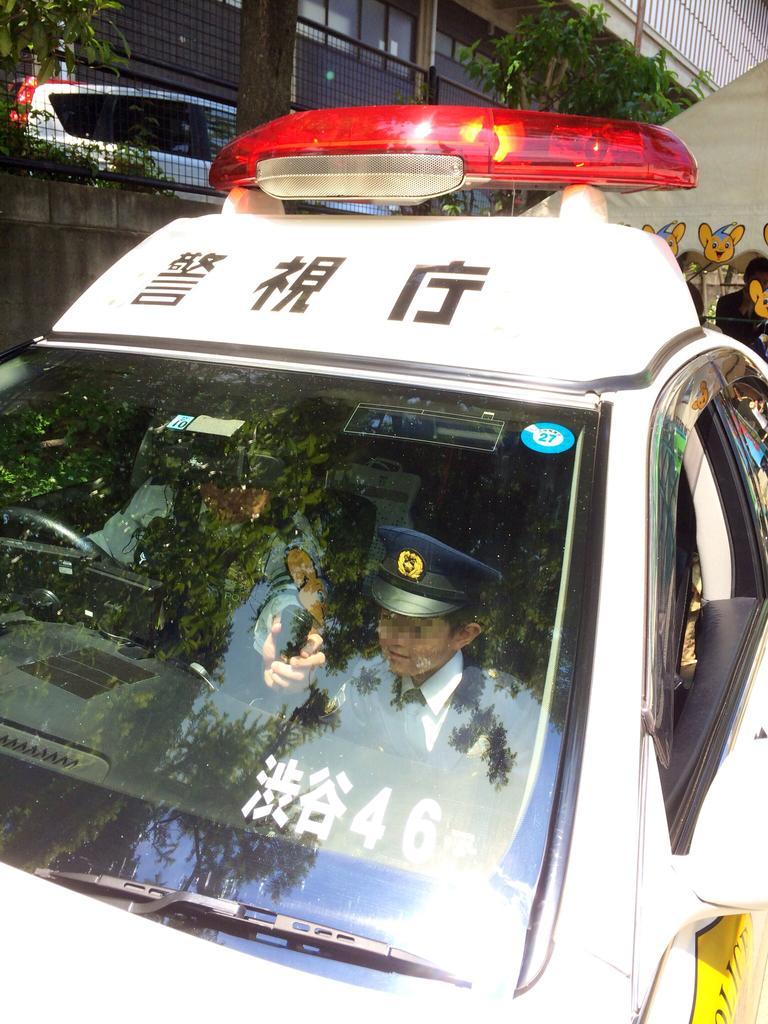Could you give a brief overview of what you see in this image? In this image we can see persons in a vehicle. In the background we can see car, wall, trees and building. 